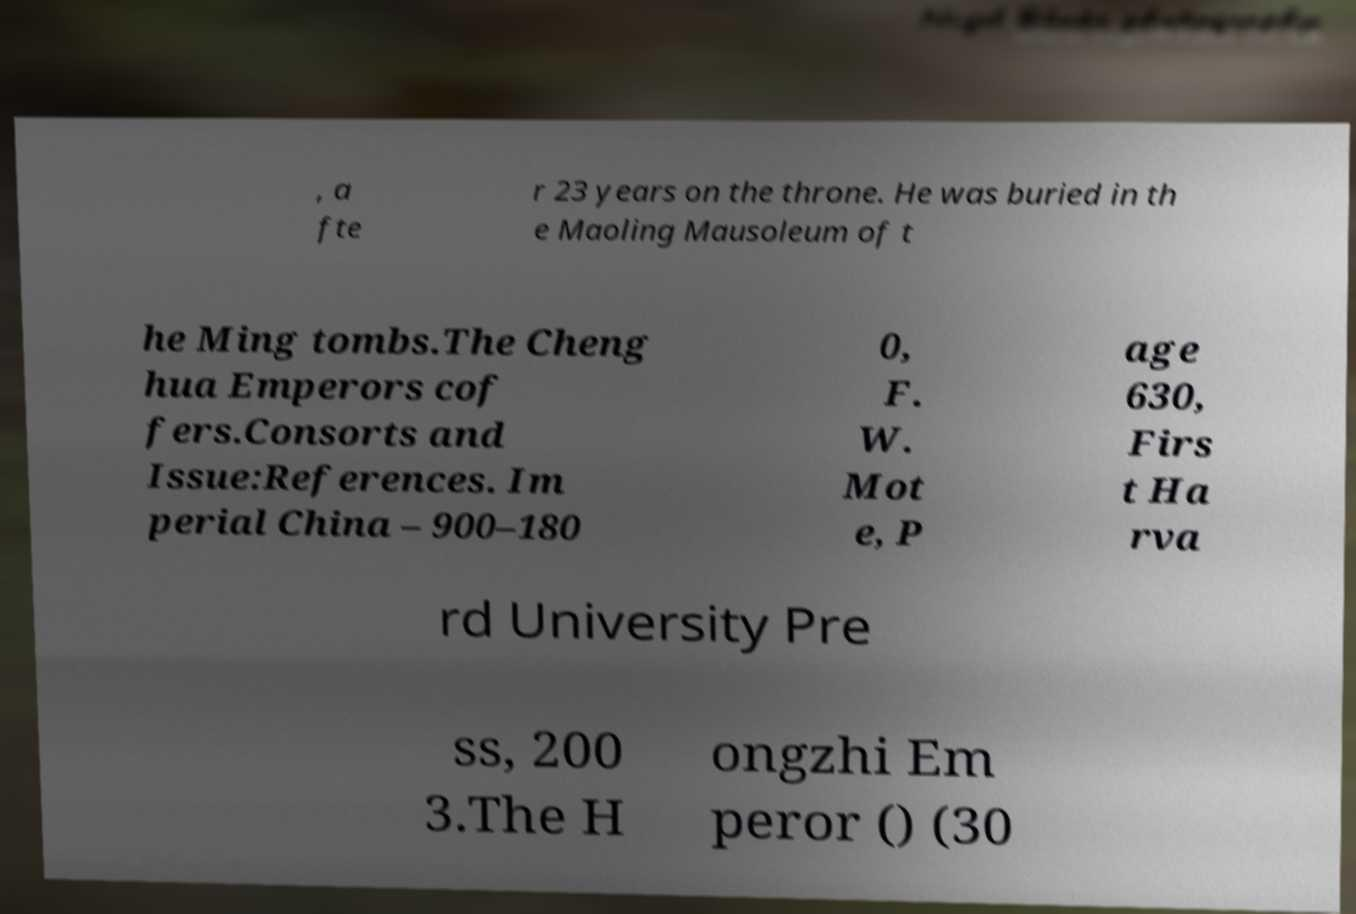Please read and relay the text visible in this image. What does it say? , a fte r 23 years on the throne. He was buried in th e Maoling Mausoleum of t he Ming tombs.The Cheng hua Emperors cof fers.Consorts and Issue:References. Im perial China – 900–180 0, F. W. Mot e, P age 630, Firs t Ha rva rd University Pre ss, 200 3.The H ongzhi Em peror () (30 